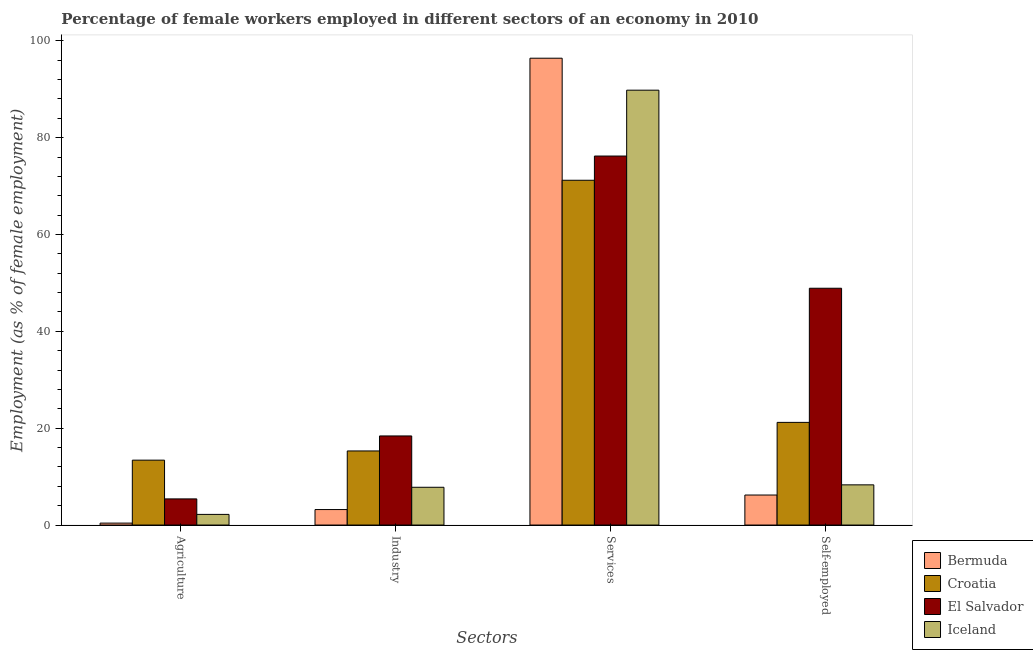How many groups of bars are there?
Provide a succinct answer. 4. Are the number of bars on each tick of the X-axis equal?
Offer a very short reply. Yes. How many bars are there on the 3rd tick from the left?
Provide a succinct answer. 4. What is the label of the 1st group of bars from the left?
Offer a very short reply. Agriculture. What is the percentage of self employed female workers in Iceland?
Provide a succinct answer. 8.3. Across all countries, what is the maximum percentage of female workers in industry?
Provide a succinct answer. 18.4. Across all countries, what is the minimum percentage of female workers in services?
Offer a terse response. 71.2. In which country was the percentage of female workers in industry maximum?
Offer a terse response. El Salvador. In which country was the percentage of female workers in agriculture minimum?
Give a very brief answer. Bermuda. What is the total percentage of female workers in services in the graph?
Keep it short and to the point. 333.6. What is the difference between the percentage of female workers in agriculture in Bermuda and that in Croatia?
Make the answer very short. -13. What is the difference between the percentage of female workers in agriculture in Iceland and the percentage of female workers in industry in Croatia?
Ensure brevity in your answer.  -13.1. What is the average percentage of female workers in industry per country?
Provide a short and direct response. 11.18. What is the difference between the percentage of female workers in services and percentage of female workers in agriculture in Bermuda?
Offer a very short reply. 96. What is the ratio of the percentage of female workers in services in Iceland to that in Bermuda?
Give a very brief answer. 0.93. Is the difference between the percentage of self employed female workers in El Salvador and Iceland greater than the difference between the percentage of female workers in services in El Salvador and Iceland?
Ensure brevity in your answer.  Yes. What is the difference between the highest and the second highest percentage of female workers in services?
Ensure brevity in your answer.  6.6. What is the difference between the highest and the lowest percentage of female workers in services?
Give a very brief answer. 25.2. Is it the case that in every country, the sum of the percentage of female workers in agriculture and percentage of female workers in industry is greater than the sum of percentage of female workers in services and percentage of self employed female workers?
Provide a short and direct response. No. What does the 1st bar from the left in Industry represents?
Provide a succinct answer. Bermuda. What does the 1st bar from the right in Services represents?
Your response must be concise. Iceland. How many bars are there?
Provide a succinct answer. 16. How many countries are there in the graph?
Your response must be concise. 4. What is the difference between two consecutive major ticks on the Y-axis?
Keep it short and to the point. 20. Are the values on the major ticks of Y-axis written in scientific E-notation?
Keep it short and to the point. No. Does the graph contain any zero values?
Your response must be concise. No. Does the graph contain grids?
Your answer should be compact. No. Where does the legend appear in the graph?
Your answer should be very brief. Bottom right. How many legend labels are there?
Keep it short and to the point. 4. What is the title of the graph?
Your answer should be very brief. Percentage of female workers employed in different sectors of an economy in 2010. Does "Dominican Republic" appear as one of the legend labels in the graph?
Your response must be concise. No. What is the label or title of the X-axis?
Provide a succinct answer. Sectors. What is the label or title of the Y-axis?
Make the answer very short. Employment (as % of female employment). What is the Employment (as % of female employment) of Bermuda in Agriculture?
Provide a short and direct response. 0.4. What is the Employment (as % of female employment) in Croatia in Agriculture?
Provide a succinct answer. 13.4. What is the Employment (as % of female employment) in El Salvador in Agriculture?
Offer a terse response. 5.4. What is the Employment (as % of female employment) of Iceland in Agriculture?
Your answer should be compact. 2.2. What is the Employment (as % of female employment) in Bermuda in Industry?
Offer a very short reply. 3.2. What is the Employment (as % of female employment) in Croatia in Industry?
Keep it short and to the point. 15.3. What is the Employment (as % of female employment) in El Salvador in Industry?
Your answer should be very brief. 18.4. What is the Employment (as % of female employment) in Iceland in Industry?
Provide a succinct answer. 7.8. What is the Employment (as % of female employment) of Bermuda in Services?
Provide a short and direct response. 96.4. What is the Employment (as % of female employment) of Croatia in Services?
Your response must be concise. 71.2. What is the Employment (as % of female employment) in El Salvador in Services?
Your answer should be compact. 76.2. What is the Employment (as % of female employment) in Iceland in Services?
Your answer should be very brief. 89.8. What is the Employment (as % of female employment) of Bermuda in Self-employed?
Give a very brief answer. 6.2. What is the Employment (as % of female employment) in Croatia in Self-employed?
Your answer should be compact. 21.2. What is the Employment (as % of female employment) of El Salvador in Self-employed?
Your answer should be compact. 48.9. What is the Employment (as % of female employment) of Iceland in Self-employed?
Keep it short and to the point. 8.3. Across all Sectors, what is the maximum Employment (as % of female employment) of Bermuda?
Your answer should be compact. 96.4. Across all Sectors, what is the maximum Employment (as % of female employment) in Croatia?
Provide a succinct answer. 71.2. Across all Sectors, what is the maximum Employment (as % of female employment) in El Salvador?
Your answer should be very brief. 76.2. Across all Sectors, what is the maximum Employment (as % of female employment) in Iceland?
Ensure brevity in your answer.  89.8. Across all Sectors, what is the minimum Employment (as % of female employment) in Bermuda?
Give a very brief answer. 0.4. Across all Sectors, what is the minimum Employment (as % of female employment) in Croatia?
Your answer should be compact. 13.4. Across all Sectors, what is the minimum Employment (as % of female employment) of El Salvador?
Provide a short and direct response. 5.4. Across all Sectors, what is the minimum Employment (as % of female employment) of Iceland?
Ensure brevity in your answer.  2.2. What is the total Employment (as % of female employment) of Bermuda in the graph?
Ensure brevity in your answer.  106.2. What is the total Employment (as % of female employment) in Croatia in the graph?
Your answer should be very brief. 121.1. What is the total Employment (as % of female employment) of El Salvador in the graph?
Give a very brief answer. 148.9. What is the total Employment (as % of female employment) in Iceland in the graph?
Your response must be concise. 108.1. What is the difference between the Employment (as % of female employment) of Bermuda in Agriculture and that in Industry?
Provide a short and direct response. -2.8. What is the difference between the Employment (as % of female employment) of Croatia in Agriculture and that in Industry?
Ensure brevity in your answer.  -1.9. What is the difference between the Employment (as % of female employment) of El Salvador in Agriculture and that in Industry?
Give a very brief answer. -13. What is the difference between the Employment (as % of female employment) in Bermuda in Agriculture and that in Services?
Make the answer very short. -96. What is the difference between the Employment (as % of female employment) in Croatia in Agriculture and that in Services?
Make the answer very short. -57.8. What is the difference between the Employment (as % of female employment) of El Salvador in Agriculture and that in Services?
Your response must be concise. -70.8. What is the difference between the Employment (as % of female employment) of Iceland in Agriculture and that in Services?
Make the answer very short. -87.6. What is the difference between the Employment (as % of female employment) in Bermuda in Agriculture and that in Self-employed?
Provide a succinct answer. -5.8. What is the difference between the Employment (as % of female employment) in Croatia in Agriculture and that in Self-employed?
Give a very brief answer. -7.8. What is the difference between the Employment (as % of female employment) of El Salvador in Agriculture and that in Self-employed?
Your response must be concise. -43.5. What is the difference between the Employment (as % of female employment) of Iceland in Agriculture and that in Self-employed?
Your response must be concise. -6.1. What is the difference between the Employment (as % of female employment) in Bermuda in Industry and that in Services?
Your answer should be compact. -93.2. What is the difference between the Employment (as % of female employment) in Croatia in Industry and that in Services?
Ensure brevity in your answer.  -55.9. What is the difference between the Employment (as % of female employment) in El Salvador in Industry and that in Services?
Your response must be concise. -57.8. What is the difference between the Employment (as % of female employment) of Iceland in Industry and that in Services?
Make the answer very short. -82. What is the difference between the Employment (as % of female employment) in Bermuda in Industry and that in Self-employed?
Give a very brief answer. -3. What is the difference between the Employment (as % of female employment) of El Salvador in Industry and that in Self-employed?
Ensure brevity in your answer.  -30.5. What is the difference between the Employment (as % of female employment) in Iceland in Industry and that in Self-employed?
Provide a succinct answer. -0.5. What is the difference between the Employment (as % of female employment) of Bermuda in Services and that in Self-employed?
Make the answer very short. 90.2. What is the difference between the Employment (as % of female employment) in El Salvador in Services and that in Self-employed?
Offer a very short reply. 27.3. What is the difference between the Employment (as % of female employment) in Iceland in Services and that in Self-employed?
Your response must be concise. 81.5. What is the difference between the Employment (as % of female employment) of Bermuda in Agriculture and the Employment (as % of female employment) of Croatia in Industry?
Give a very brief answer. -14.9. What is the difference between the Employment (as % of female employment) of Bermuda in Agriculture and the Employment (as % of female employment) of El Salvador in Industry?
Keep it short and to the point. -18. What is the difference between the Employment (as % of female employment) of Bermuda in Agriculture and the Employment (as % of female employment) of Iceland in Industry?
Your response must be concise. -7.4. What is the difference between the Employment (as % of female employment) in Croatia in Agriculture and the Employment (as % of female employment) in El Salvador in Industry?
Provide a succinct answer. -5. What is the difference between the Employment (as % of female employment) in Croatia in Agriculture and the Employment (as % of female employment) in Iceland in Industry?
Your response must be concise. 5.6. What is the difference between the Employment (as % of female employment) of El Salvador in Agriculture and the Employment (as % of female employment) of Iceland in Industry?
Offer a terse response. -2.4. What is the difference between the Employment (as % of female employment) of Bermuda in Agriculture and the Employment (as % of female employment) of Croatia in Services?
Your answer should be very brief. -70.8. What is the difference between the Employment (as % of female employment) of Bermuda in Agriculture and the Employment (as % of female employment) of El Salvador in Services?
Keep it short and to the point. -75.8. What is the difference between the Employment (as % of female employment) of Bermuda in Agriculture and the Employment (as % of female employment) of Iceland in Services?
Your answer should be very brief. -89.4. What is the difference between the Employment (as % of female employment) of Croatia in Agriculture and the Employment (as % of female employment) of El Salvador in Services?
Offer a very short reply. -62.8. What is the difference between the Employment (as % of female employment) in Croatia in Agriculture and the Employment (as % of female employment) in Iceland in Services?
Your answer should be compact. -76.4. What is the difference between the Employment (as % of female employment) in El Salvador in Agriculture and the Employment (as % of female employment) in Iceland in Services?
Your answer should be very brief. -84.4. What is the difference between the Employment (as % of female employment) in Bermuda in Agriculture and the Employment (as % of female employment) in Croatia in Self-employed?
Provide a short and direct response. -20.8. What is the difference between the Employment (as % of female employment) of Bermuda in Agriculture and the Employment (as % of female employment) of El Salvador in Self-employed?
Provide a short and direct response. -48.5. What is the difference between the Employment (as % of female employment) in Bermuda in Agriculture and the Employment (as % of female employment) in Iceland in Self-employed?
Give a very brief answer. -7.9. What is the difference between the Employment (as % of female employment) in Croatia in Agriculture and the Employment (as % of female employment) in El Salvador in Self-employed?
Your answer should be compact. -35.5. What is the difference between the Employment (as % of female employment) in Bermuda in Industry and the Employment (as % of female employment) in Croatia in Services?
Give a very brief answer. -68. What is the difference between the Employment (as % of female employment) in Bermuda in Industry and the Employment (as % of female employment) in El Salvador in Services?
Your answer should be very brief. -73. What is the difference between the Employment (as % of female employment) in Bermuda in Industry and the Employment (as % of female employment) in Iceland in Services?
Make the answer very short. -86.6. What is the difference between the Employment (as % of female employment) in Croatia in Industry and the Employment (as % of female employment) in El Salvador in Services?
Your answer should be very brief. -60.9. What is the difference between the Employment (as % of female employment) in Croatia in Industry and the Employment (as % of female employment) in Iceland in Services?
Ensure brevity in your answer.  -74.5. What is the difference between the Employment (as % of female employment) of El Salvador in Industry and the Employment (as % of female employment) of Iceland in Services?
Your response must be concise. -71.4. What is the difference between the Employment (as % of female employment) of Bermuda in Industry and the Employment (as % of female employment) of El Salvador in Self-employed?
Your answer should be compact. -45.7. What is the difference between the Employment (as % of female employment) of Bermuda in Industry and the Employment (as % of female employment) of Iceland in Self-employed?
Your answer should be very brief. -5.1. What is the difference between the Employment (as % of female employment) in Croatia in Industry and the Employment (as % of female employment) in El Salvador in Self-employed?
Your answer should be compact. -33.6. What is the difference between the Employment (as % of female employment) in Croatia in Industry and the Employment (as % of female employment) in Iceland in Self-employed?
Ensure brevity in your answer.  7. What is the difference between the Employment (as % of female employment) in Bermuda in Services and the Employment (as % of female employment) in Croatia in Self-employed?
Provide a succinct answer. 75.2. What is the difference between the Employment (as % of female employment) of Bermuda in Services and the Employment (as % of female employment) of El Salvador in Self-employed?
Offer a very short reply. 47.5. What is the difference between the Employment (as % of female employment) of Bermuda in Services and the Employment (as % of female employment) of Iceland in Self-employed?
Your answer should be very brief. 88.1. What is the difference between the Employment (as % of female employment) in Croatia in Services and the Employment (as % of female employment) in El Salvador in Self-employed?
Your response must be concise. 22.3. What is the difference between the Employment (as % of female employment) in Croatia in Services and the Employment (as % of female employment) in Iceland in Self-employed?
Keep it short and to the point. 62.9. What is the difference between the Employment (as % of female employment) of El Salvador in Services and the Employment (as % of female employment) of Iceland in Self-employed?
Provide a succinct answer. 67.9. What is the average Employment (as % of female employment) in Bermuda per Sectors?
Offer a terse response. 26.55. What is the average Employment (as % of female employment) of Croatia per Sectors?
Offer a terse response. 30.27. What is the average Employment (as % of female employment) in El Salvador per Sectors?
Provide a short and direct response. 37.23. What is the average Employment (as % of female employment) in Iceland per Sectors?
Keep it short and to the point. 27.02. What is the difference between the Employment (as % of female employment) in Bermuda and Employment (as % of female employment) in Iceland in Agriculture?
Offer a very short reply. -1.8. What is the difference between the Employment (as % of female employment) in Croatia and Employment (as % of female employment) in Iceland in Agriculture?
Provide a short and direct response. 11.2. What is the difference between the Employment (as % of female employment) in El Salvador and Employment (as % of female employment) in Iceland in Agriculture?
Keep it short and to the point. 3.2. What is the difference between the Employment (as % of female employment) of Bermuda and Employment (as % of female employment) of Croatia in Industry?
Ensure brevity in your answer.  -12.1. What is the difference between the Employment (as % of female employment) of Bermuda and Employment (as % of female employment) of El Salvador in Industry?
Offer a very short reply. -15.2. What is the difference between the Employment (as % of female employment) in Bermuda and Employment (as % of female employment) in Iceland in Industry?
Provide a short and direct response. -4.6. What is the difference between the Employment (as % of female employment) of Croatia and Employment (as % of female employment) of Iceland in Industry?
Provide a short and direct response. 7.5. What is the difference between the Employment (as % of female employment) of El Salvador and Employment (as % of female employment) of Iceland in Industry?
Make the answer very short. 10.6. What is the difference between the Employment (as % of female employment) in Bermuda and Employment (as % of female employment) in Croatia in Services?
Make the answer very short. 25.2. What is the difference between the Employment (as % of female employment) of Bermuda and Employment (as % of female employment) of El Salvador in Services?
Your answer should be compact. 20.2. What is the difference between the Employment (as % of female employment) of Bermuda and Employment (as % of female employment) of Iceland in Services?
Provide a succinct answer. 6.6. What is the difference between the Employment (as % of female employment) of Croatia and Employment (as % of female employment) of Iceland in Services?
Offer a terse response. -18.6. What is the difference between the Employment (as % of female employment) of El Salvador and Employment (as % of female employment) of Iceland in Services?
Your response must be concise. -13.6. What is the difference between the Employment (as % of female employment) in Bermuda and Employment (as % of female employment) in Croatia in Self-employed?
Your answer should be very brief. -15. What is the difference between the Employment (as % of female employment) of Bermuda and Employment (as % of female employment) of El Salvador in Self-employed?
Provide a succinct answer. -42.7. What is the difference between the Employment (as % of female employment) in Croatia and Employment (as % of female employment) in El Salvador in Self-employed?
Make the answer very short. -27.7. What is the difference between the Employment (as % of female employment) in Croatia and Employment (as % of female employment) in Iceland in Self-employed?
Your answer should be compact. 12.9. What is the difference between the Employment (as % of female employment) of El Salvador and Employment (as % of female employment) of Iceland in Self-employed?
Provide a short and direct response. 40.6. What is the ratio of the Employment (as % of female employment) in Croatia in Agriculture to that in Industry?
Ensure brevity in your answer.  0.88. What is the ratio of the Employment (as % of female employment) in El Salvador in Agriculture to that in Industry?
Offer a very short reply. 0.29. What is the ratio of the Employment (as % of female employment) of Iceland in Agriculture to that in Industry?
Offer a terse response. 0.28. What is the ratio of the Employment (as % of female employment) in Bermuda in Agriculture to that in Services?
Offer a terse response. 0. What is the ratio of the Employment (as % of female employment) in Croatia in Agriculture to that in Services?
Keep it short and to the point. 0.19. What is the ratio of the Employment (as % of female employment) of El Salvador in Agriculture to that in Services?
Offer a very short reply. 0.07. What is the ratio of the Employment (as % of female employment) in Iceland in Agriculture to that in Services?
Offer a terse response. 0.02. What is the ratio of the Employment (as % of female employment) of Bermuda in Agriculture to that in Self-employed?
Your answer should be very brief. 0.06. What is the ratio of the Employment (as % of female employment) of Croatia in Agriculture to that in Self-employed?
Make the answer very short. 0.63. What is the ratio of the Employment (as % of female employment) of El Salvador in Agriculture to that in Self-employed?
Ensure brevity in your answer.  0.11. What is the ratio of the Employment (as % of female employment) in Iceland in Agriculture to that in Self-employed?
Give a very brief answer. 0.27. What is the ratio of the Employment (as % of female employment) of Bermuda in Industry to that in Services?
Your answer should be compact. 0.03. What is the ratio of the Employment (as % of female employment) in Croatia in Industry to that in Services?
Your response must be concise. 0.21. What is the ratio of the Employment (as % of female employment) in El Salvador in Industry to that in Services?
Provide a succinct answer. 0.24. What is the ratio of the Employment (as % of female employment) of Iceland in Industry to that in Services?
Provide a succinct answer. 0.09. What is the ratio of the Employment (as % of female employment) in Bermuda in Industry to that in Self-employed?
Give a very brief answer. 0.52. What is the ratio of the Employment (as % of female employment) in Croatia in Industry to that in Self-employed?
Your answer should be very brief. 0.72. What is the ratio of the Employment (as % of female employment) of El Salvador in Industry to that in Self-employed?
Give a very brief answer. 0.38. What is the ratio of the Employment (as % of female employment) in Iceland in Industry to that in Self-employed?
Provide a succinct answer. 0.94. What is the ratio of the Employment (as % of female employment) in Bermuda in Services to that in Self-employed?
Your response must be concise. 15.55. What is the ratio of the Employment (as % of female employment) in Croatia in Services to that in Self-employed?
Your answer should be very brief. 3.36. What is the ratio of the Employment (as % of female employment) in El Salvador in Services to that in Self-employed?
Give a very brief answer. 1.56. What is the ratio of the Employment (as % of female employment) in Iceland in Services to that in Self-employed?
Your response must be concise. 10.82. What is the difference between the highest and the second highest Employment (as % of female employment) in Bermuda?
Ensure brevity in your answer.  90.2. What is the difference between the highest and the second highest Employment (as % of female employment) in Croatia?
Offer a very short reply. 50. What is the difference between the highest and the second highest Employment (as % of female employment) of El Salvador?
Ensure brevity in your answer.  27.3. What is the difference between the highest and the second highest Employment (as % of female employment) of Iceland?
Provide a short and direct response. 81.5. What is the difference between the highest and the lowest Employment (as % of female employment) of Bermuda?
Ensure brevity in your answer.  96. What is the difference between the highest and the lowest Employment (as % of female employment) in Croatia?
Your answer should be very brief. 57.8. What is the difference between the highest and the lowest Employment (as % of female employment) of El Salvador?
Ensure brevity in your answer.  70.8. What is the difference between the highest and the lowest Employment (as % of female employment) of Iceland?
Keep it short and to the point. 87.6. 